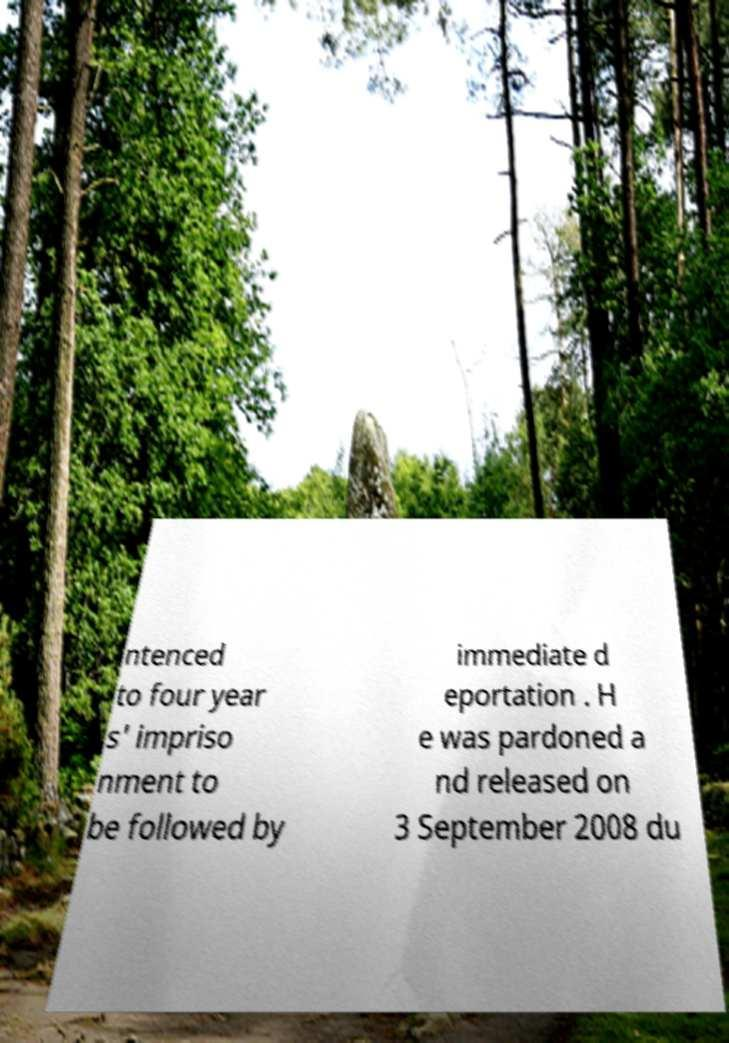There's text embedded in this image that I need extracted. Can you transcribe it verbatim? ntenced to four year s' impriso nment to be followed by immediate d eportation . H e was pardoned a nd released on 3 September 2008 du 